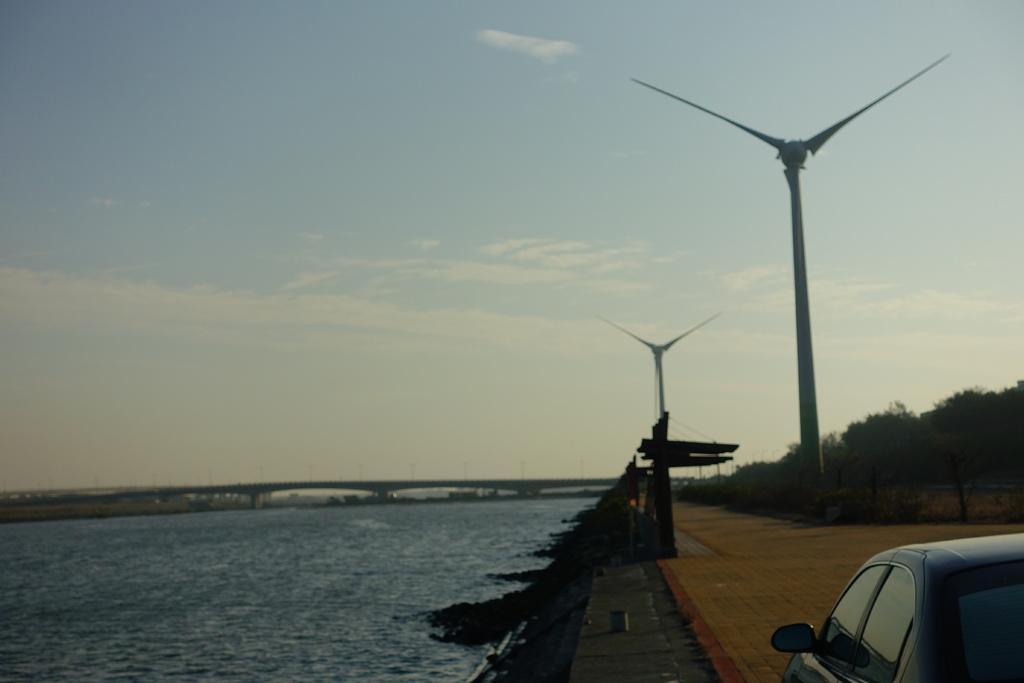Can you describe this image briefly? In this picture we can see water at the bottom, in the background there is a bridge, we can see some trees and two windmills on the right side, there is a car at the right bottom, we can see the sky at the top of the picture. 